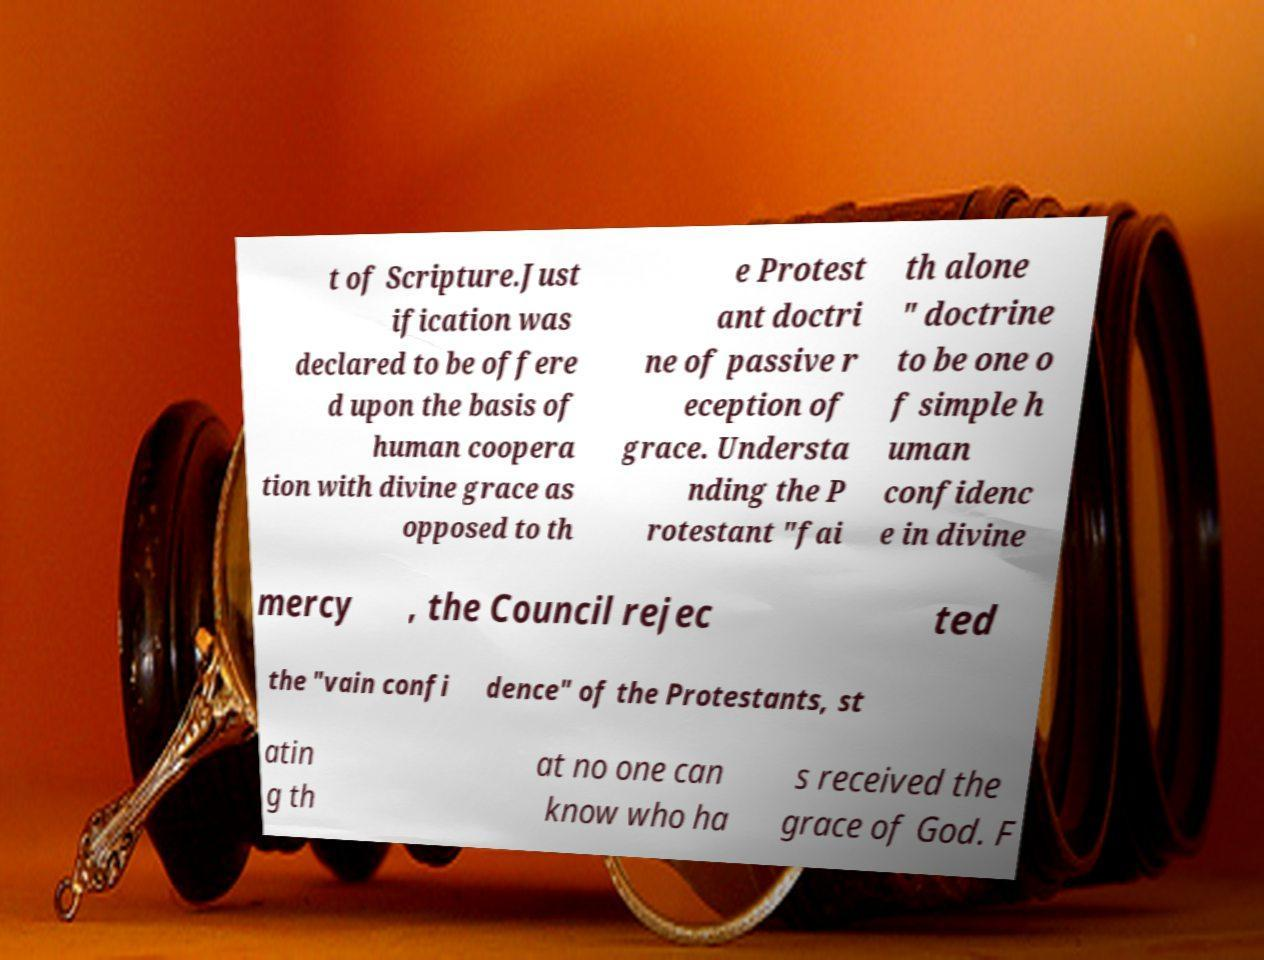For documentation purposes, I need the text within this image transcribed. Could you provide that? t of Scripture.Just ification was declared to be offere d upon the basis of human coopera tion with divine grace as opposed to th e Protest ant doctri ne of passive r eception of grace. Understa nding the P rotestant "fai th alone " doctrine to be one o f simple h uman confidenc e in divine mercy , the Council rejec ted the "vain confi dence" of the Protestants, st atin g th at no one can know who ha s received the grace of God. F 